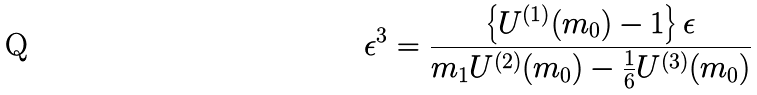<formula> <loc_0><loc_0><loc_500><loc_500>\epsilon ^ { 3 } = \frac { \left \{ U ^ { ( 1 ) } ( m _ { 0 } ) - 1 \right \} \epsilon } { m _ { 1 } U ^ { ( 2 ) } ( m _ { 0 } ) - \frac { 1 } { 6 } U ^ { ( 3 ) } ( m _ { 0 } ) }</formula> 